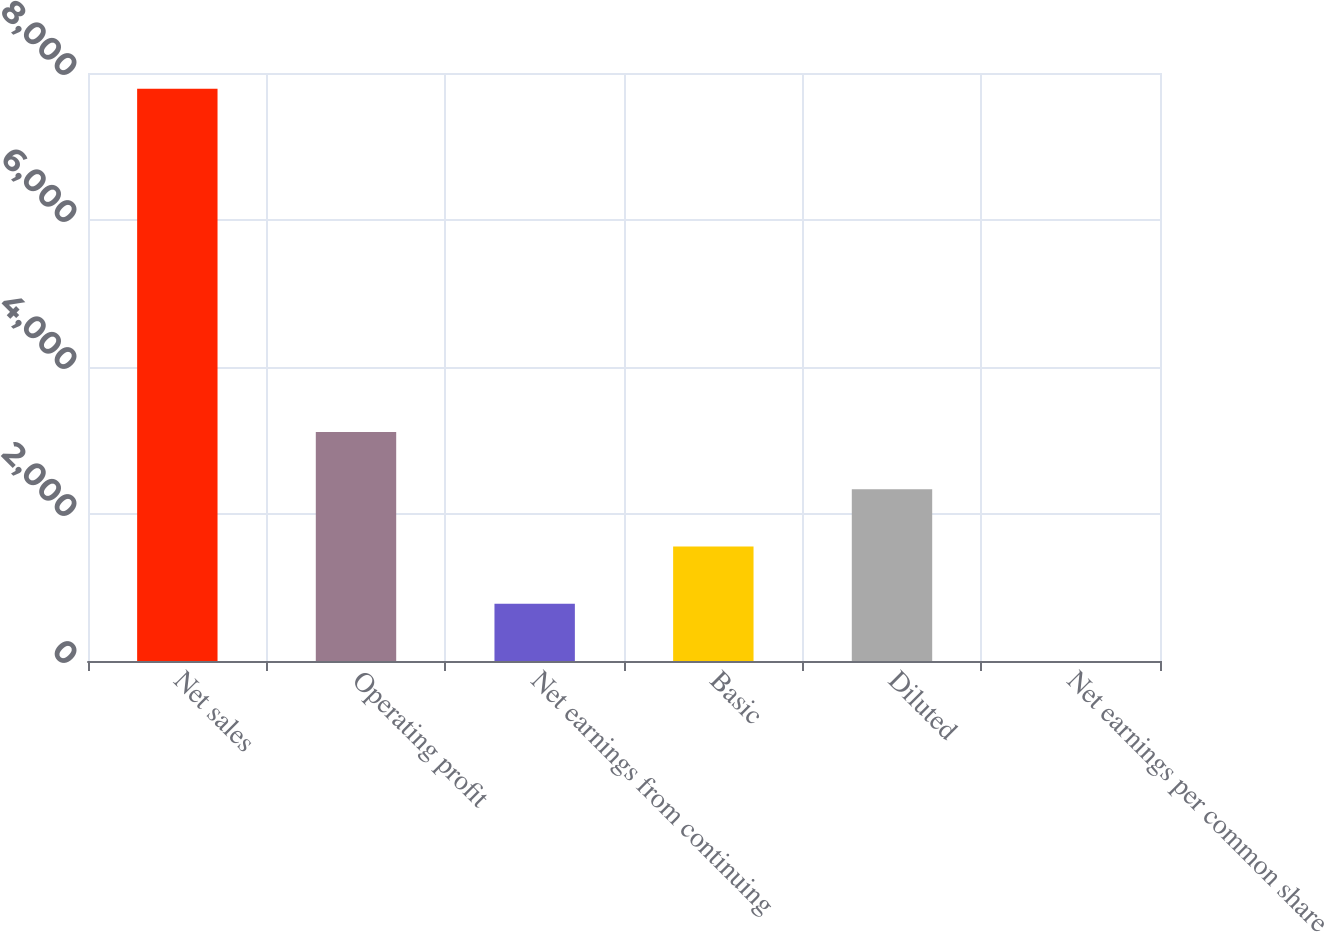Convert chart. <chart><loc_0><loc_0><loc_500><loc_500><bar_chart><fcel>Net sales<fcel>Operating profit<fcel>Net earnings from continuing<fcel>Basic<fcel>Diluted<fcel>Net earnings per common share<nl><fcel>7785<fcel>3114.32<fcel>779<fcel>1557.44<fcel>2335.88<fcel>0.56<nl></chart> 